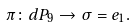<formula> <loc_0><loc_0><loc_500><loc_500>\pi \colon d P _ { 9 } \to \sigma = e _ { 1 } .</formula> 